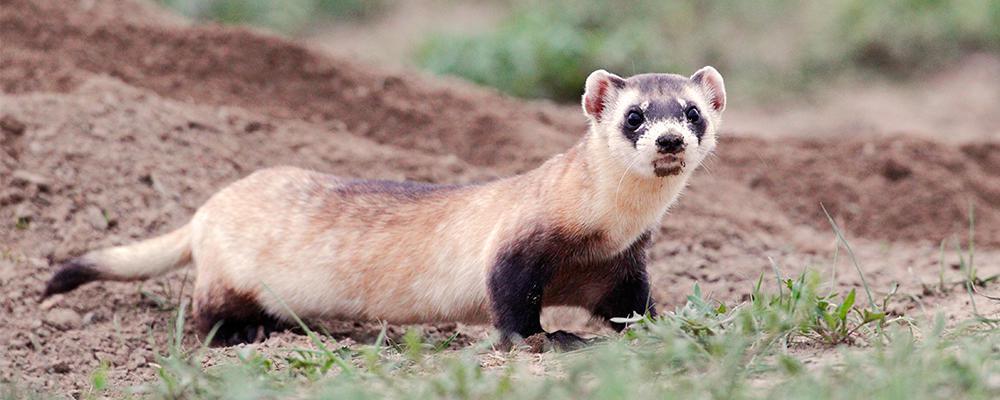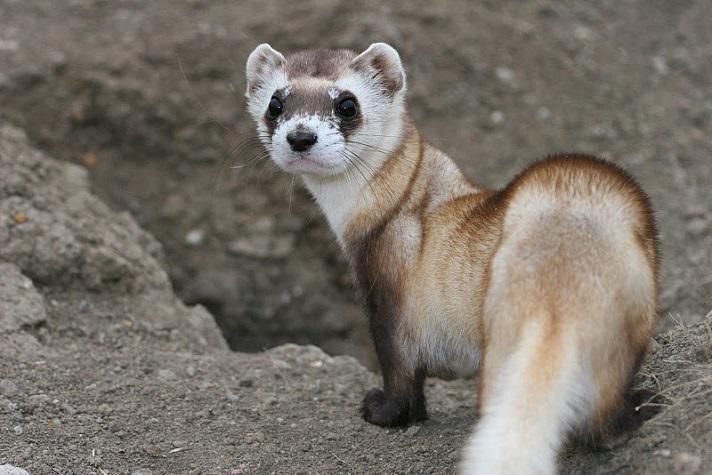The first image is the image on the left, the second image is the image on the right. Assess this claim about the two images: "The animal in the image on the right is holding one paw off the ground.". Correct or not? Answer yes or no. No. The first image is the image on the left, the second image is the image on the right. Evaluate the accuracy of this statement regarding the images: "A total of two ferrets are shown, each of them fully above ground.". Is it true? Answer yes or no. Yes. 